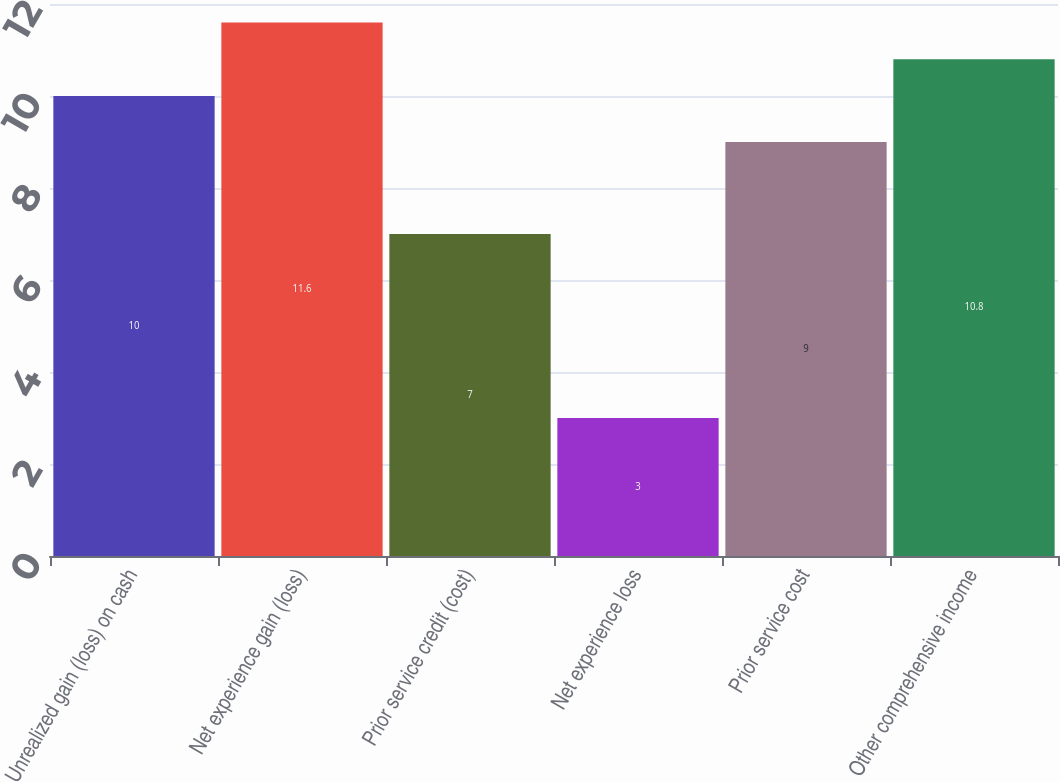<chart> <loc_0><loc_0><loc_500><loc_500><bar_chart><fcel>Unrealized gain (loss) on cash<fcel>Net experience gain (loss)<fcel>Prior service credit (cost)<fcel>Net experience loss<fcel>Prior service cost<fcel>Other comprehensive income<nl><fcel>10<fcel>11.6<fcel>7<fcel>3<fcel>9<fcel>10.8<nl></chart> 